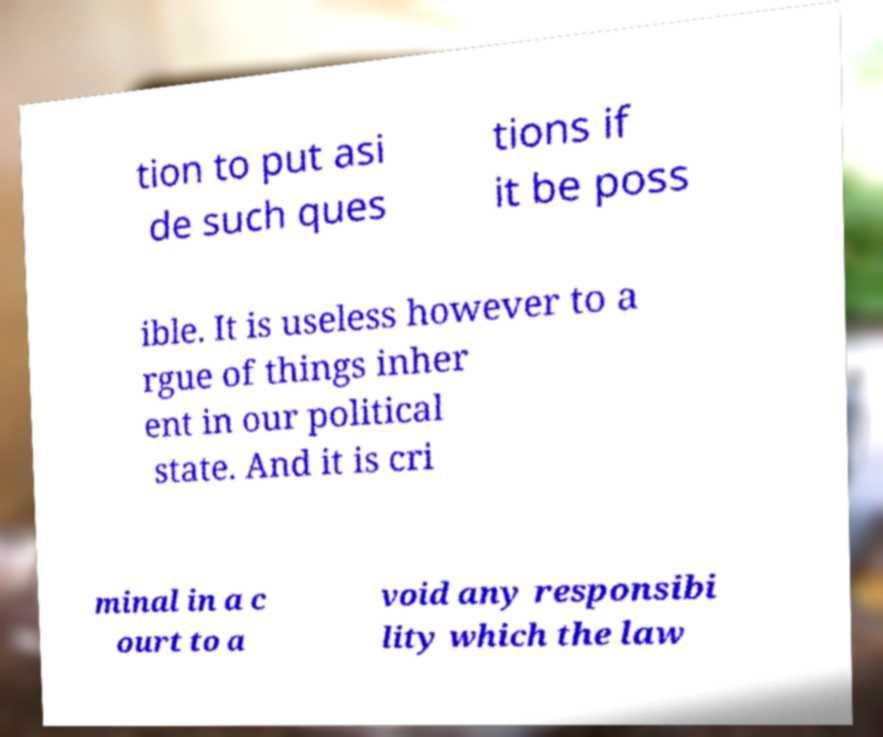Please identify and transcribe the text found in this image. tion to put asi de such ques tions if it be poss ible. It is useless however to a rgue of things inher ent in our political state. And it is cri minal in a c ourt to a void any responsibi lity which the law 